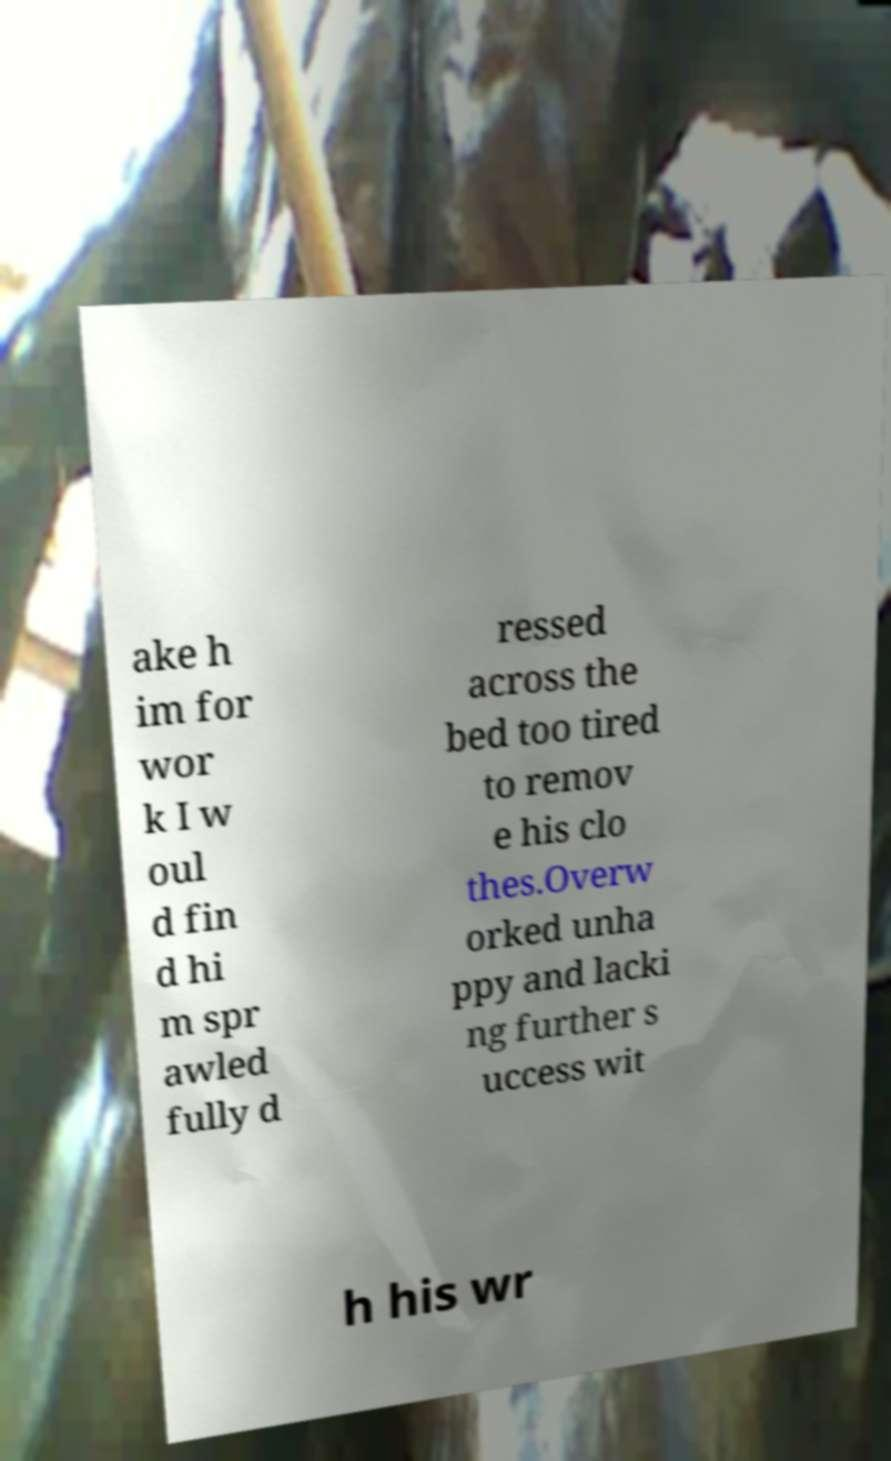Could you assist in decoding the text presented in this image and type it out clearly? ake h im for wor k I w oul d fin d hi m spr awled fully d ressed across the bed too tired to remov e his clo thes.Overw orked unha ppy and lacki ng further s uccess wit h his wr 